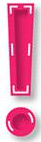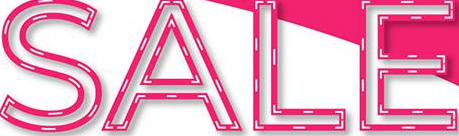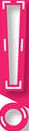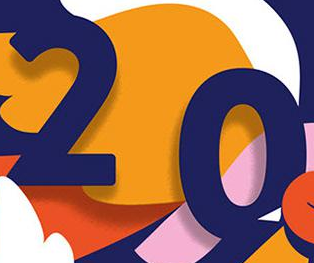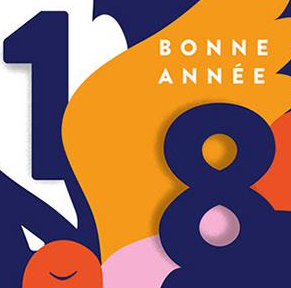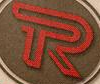What words are shown in these images in order, separated by a semicolon? !; SALE; !; 20; 18; R 